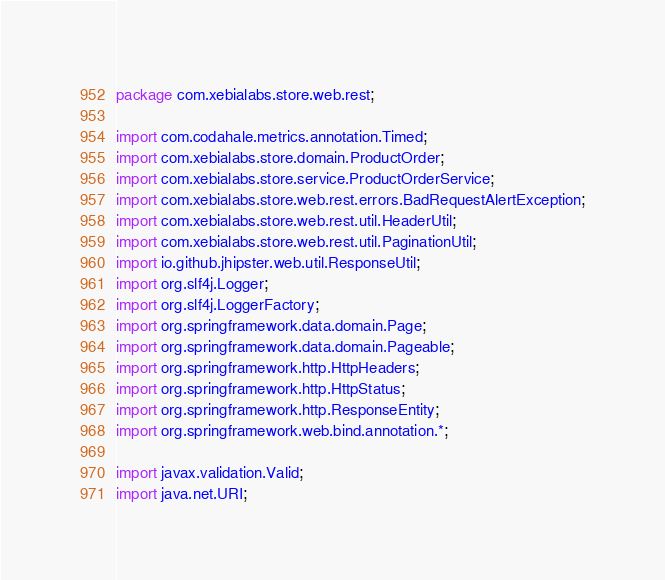<code> <loc_0><loc_0><loc_500><loc_500><_Java_>package com.xebialabs.store.web.rest;

import com.codahale.metrics.annotation.Timed;
import com.xebialabs.store.domain.ProductOrder;
import com.xebialabs.store.service.ProductOrderService;
import com.xebialabs.store.web.rest.errors.BadRequestAlertException;
import com.xebialabs.store.web.rest.util.HeaderUtil;
import com.xebialabs.store.web.rest.util.PaginationUtil;
import io.github.jhipster.web.util.ResponseUtil;
import org.slf4j.Logger;
import org.slf4j.LoggerFactory;
import org.springframework.data.domain.Page;
import org.springframework.data.domain.Pageable;
import org.springframework.http.HttpHeaders;
import org.springframework.http.HttpStatus;
import org.springframework.http.ResponseEntity;
import org.springframework.web.bind.annotation.*;

import javax.validation.Valid;
import java.net.URI;</code> 